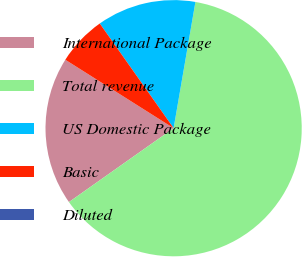Convert chart to OTSL. <chart><loc_0><loc_0><loc_500><loc_500><pie_chart><fcel>International Package<fcel>Total revenue<fcel>US Domestic Package<fcel>Basic<fcel>Diluted<nl><fcel>18.75%<fcel>62.49%<fcel>12.5%<fcel>6.25%<fcel>0.0%<nl></chart> 